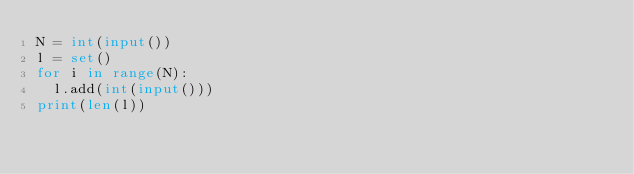<code> <loc_0><loc_0><loc_500><loc_500><_Python_>N = int(input())
l = set()
for i in range(N):
  l.add(int(input()))
print(len(l))</code> 